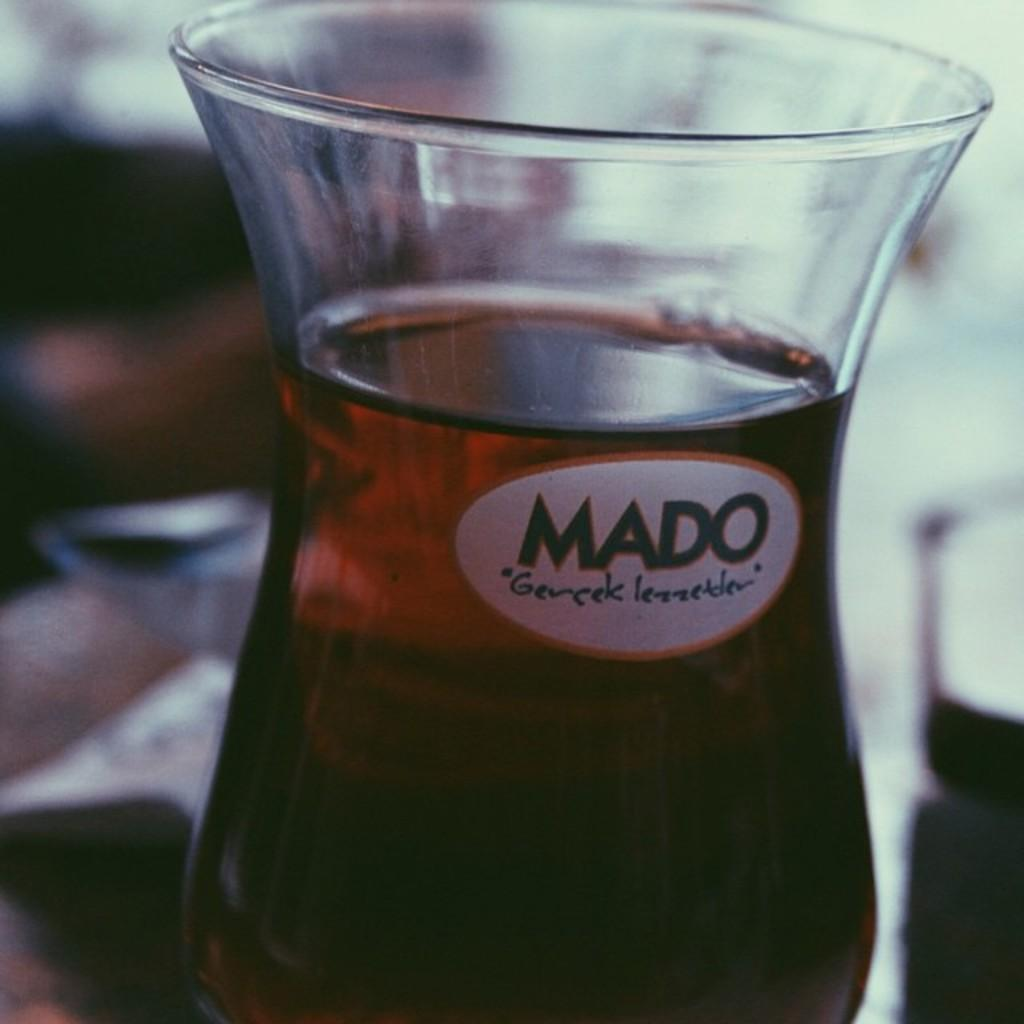What object is present in the image that can hold a liquid? There is a glass in the image. What is inside the glass? The glass is filled with a drink. Can you describe the background of the glass? The background of the glass is blurry. How many rabbits can be seen playing on the seashore in the image? There are no rabbits or seashore present in the image. What arithmetic problem is being solved on the glass in the image? There is no arithmetic problem visible on the glass in the image. 